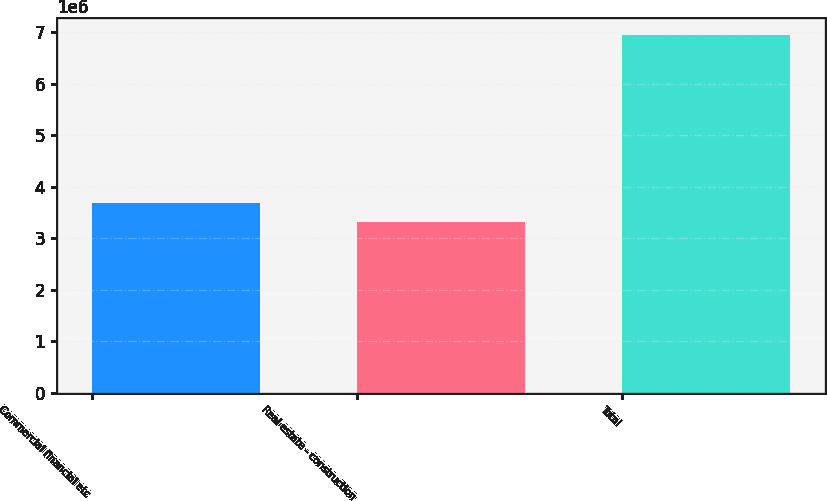<chart> <loc_0><loc_0><loc_500><loc_500><bar_chart><fcel>Commercial financial etc<fcel>Real estate - construction<fcel>Total<nl><fcel>3.68646e+06<fcel>3.32479e+06<fcel>6.9415e+06<nl></chart> 